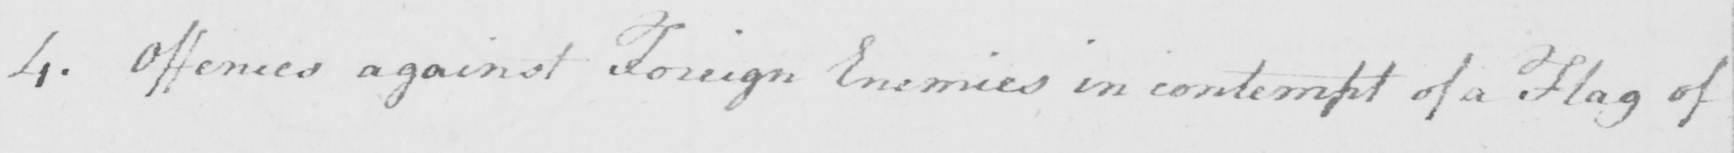Can you read and transcribe this handwriting? 4 . Offences against Foreign Enemies in contempt of a Flag of 